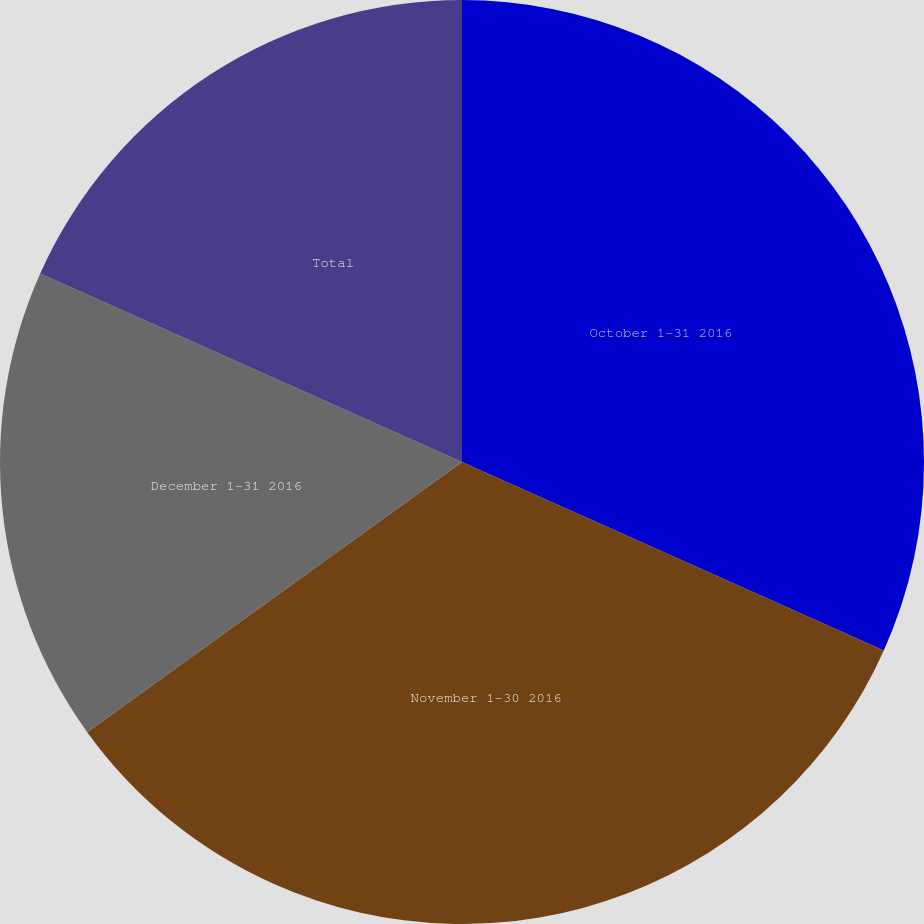<chart> <loc_0><loc_0><loc_500><loc_500><pie_chart><fcel>October 1-31 2016<fcel>November 1-30 2016<fcel>December 1-31 2016<fcel>Total<nl><fcel>31.69%<fcel>33.37%<fcel>16.63%<fcel>18.31%<nl></chart> 